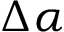Convert formula to latex. <formula><loc_0><loc_0><loc_500><loc_500>\Delta \alpha</formula> 